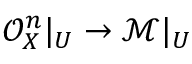Convert formula to latex. <formula><loc_0><loc_0><loc_500><loc_500>{ \mathcal { O } } _ { X } ^ { n } | _ { U } \to { \mathcal { M } } | _ { U }</formula> 